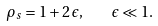Convert formula to latex. <formula><loc_0><loc_0><loc_500><loc_500>\rho _ { s } = 1 + 2 \, \epsilon , \quad \epsilon \ll 1 .</formula> 